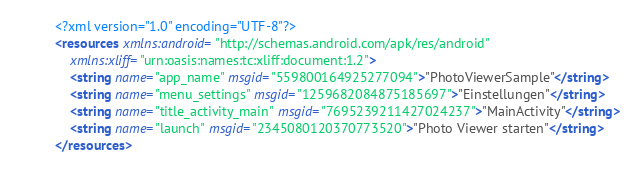<code> <loc_0><loc_0><loc_500><loc_500><_XML_><?xml version="1.0" encoding="UTF-8"?>
<resources xmlns:android="http://schemas.android.com/apk/res/android"
    xmlns:xliff="urn:oasis:names:tc:xliff:document:1.2">
    <string name="app_name" msgid="559800164925277094">"PhotoViewerSample"</string>
    <string name="menu_settings" msgid="1259682084875185697">"Einstellungen"</string>
    <string name="title_activity_main" msgid="7695239211427024237">"MainActivity"</string>
    <string name="launch" msgid="2345080120370773520">"Photo Viewer starten"</string>
</resources>
</code> 